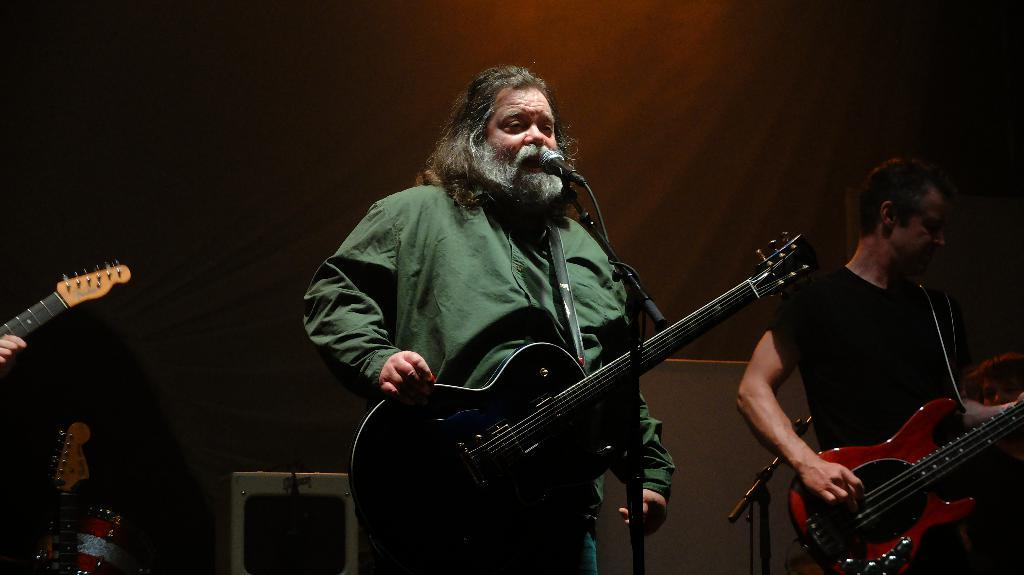What is the main subject of the image? There is a person in the image. What is the person doing in the image? The person is standing and holding a guitar. What else is the person doing with the guitar? The person is singing into a microphone. What type of soap is the person using to clean the guitar in the image? There is no soap or cleaning activity present in the image; the person is simply holding a guitar and singing into a microphone. 